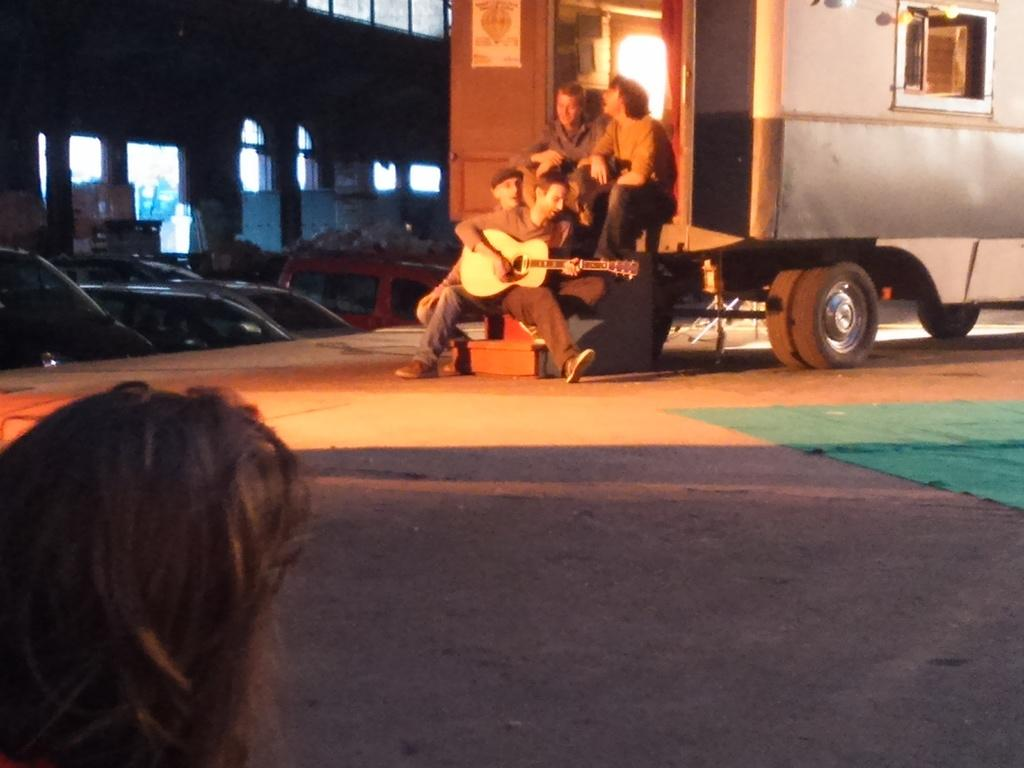What is the main subject of the image? The main subject of the image is a truck. What are the people in the image doing? People are seated on the stairs of the truck. What activity is taking place in the image? A man is playing a guitar. What else can be seen in the image? There are parked on the side. What time of day is it at the lake in the image? There is no lake present in the image, so it is not possible to determine the time of day. 